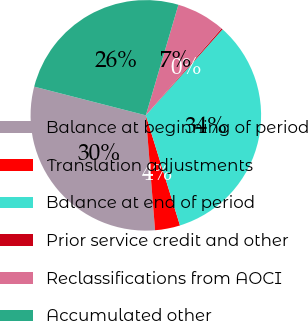Convert chart. <chart><loc_0><loc_0><loc_500><loc_500><pie_chart><fcel>Balance at beginning of period<fcel>Translation adjustments<fcel>Balance at end of period<fcel>Prior service credit and other<fcel>Reclassifications from AOCI<fcel>Accumulated other<nl><fcel>30.28%<fcel>3.51%<fcel>33.62%<fcel>0.18%<fcel>6.85%<fcel>25.55%<nl></chart> 